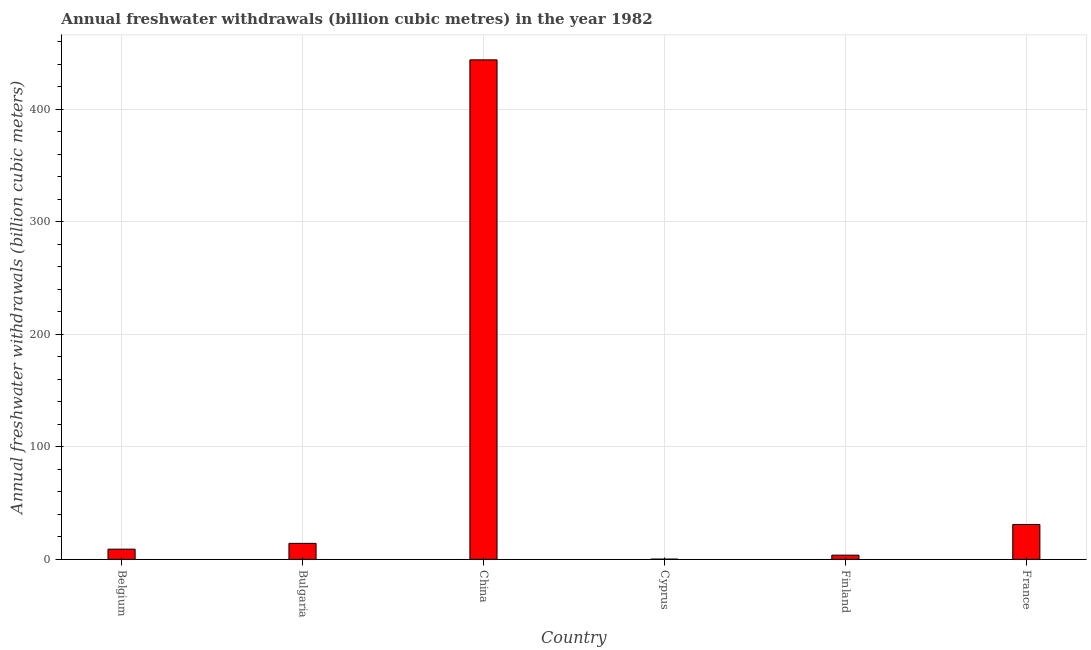Does the graph contain any zero values?
Offer a terse response. No. Does the graph contain grids?
Offer a very short reply. Yes. What is the title of the graph?
Your answer should be compact. Annual freshwater withdrawals (billion cubic metres) in the year 1982. What is the label or title of the Y-axis?
Keep it short and to the point. Annual freshwater withdrawals (billion cubic meters). What is the annual freshwater withdrawals in China?
Your answer should be compact. 443.7. Across all countries, what is the maximum annual freshwater withdrawals?
Provide a succinct answer. 443.7. Across all countries, what is the minimum annual freshwater withdrawals?
Give a very brief answer. 0.18. In which country was the annual freshwater withdrawals maximum?
Ensure brevity in your answer.  China. In which country was the annual freshwater withdrawals minimum?
Make the answer very short. Cyprus. What is the sum of the annual freshwater withdrawals?
Ensure brevity in your answer.  501.76. What is the difference between the annual freshwater withdrawals in Belgium and Finland?
Offer a very short reply. 5.33. What is the average annual freshwater withdrawals per country?
Provide a short and direct response. 83.63. What is the median annual freshwater withdrawals?
Your answer should be very brief. 11.61. What is the ratio of the annual freshwater withdrawals in Bulgaria to that in France?
Provide a succinct answer. 0.46. Is the annual freshwater withdrawals in Belgium less than that in China?
Your answer should be compact. Yes. Is the difference between the annual freshwater withdrawals in China and Cyprus greater than the difference between any two countries?
Offer a very short reply. Yes. What is the difference between the highest and the second highest annual freshwater withdrawals?
Your answer should be very brief. 412.73. Is the sum of the annual freshwater withdrawals in China and France greater than the maximum annual freshwater withdrawals across all countries?
Keep it short and to the point. Yes. What is the difference between the highest and the lowest annual freshwater withdrawals?
Provide a succinct answer. 443.52. In how many countries, is the annual freshwater withdrawals greater than the average annual freshwater withdrawals taken over all countries?
Ensure brevity in your answer.  1. How many bars are there?
Your answer should be very brief. 6. What is the difference between two consecutive major ticks on the Y-axis?
Keep it short and to the point. 100. What is the Annual freshwater withdrawals (billion cubic meters) in Belgium?
Offer a very short reply. 9.03. What is the Annual freshwater withdrawals (billion cubic meters) of Bulgaria?
Offer a very short reply. 14.18. What is the Annual freshwater withdrawals (billion cubic meters) in China?
Make the answer very short. 443.7. What is the Annual freshwater withdrawals (billion cubic meters) of Cyprus?
Ensure brevity in your answer.  0.18. What is the Annual freshwater withdrawals (billion cubic meters) of Finland?
Your answer should be compact. 3.7. What is the Annual freshwater withdrawals (billion cubic meters) in France?
Offer a terse response. 30.97. What is the difference between the Annual freshwater withdrawals (billion cubic meters) in Belgium and Bulgaria?
Your answer should be compact. -5.15. What is the difference between the Annual freshwater withdrawals (billion cubic meters) in Belgium and China?
Provide a short and direct response. -434.67. What is the difference between the Annual freshwater withdrawals (billion cubic meters) in Belgium and Cyprus?
Keep it short and to the point. 8.85. What is the difference between the Annual freshwater withdrawals (billion cubic meters) in Belgium and Finland?
Your answer should be very brief. 5.33. What is the difference between the Annual freshwater withdrawals (billion cubic meters) in Belgium and France?
Make the answer very short. -21.94. What is the difference between the Annual freshwater withdrawals (billion cubic meters) in Bulgaria and China?
Your answer should be compact. -429.52. What is the difference between the Annual freshwater withdrawals (billion cubic meters) in Bulgaria and Cyprus?
Give a very brief answer. 14. What is the difference between the Annual freshwater withdrawals (billion cubic meters) in Bulgaria and Finland?
Provide a short and direct response. 10.48. What is the difference between the Annual freshwater withdrawals (billion cubic meters) in Bulgaria and France?
Make the answer very short. -16.79. What is the difference between the Annual freshwater withdrawals (billion cubic meters) in China and Cyprus?
Keep it short and to the point. 443.52. What is the difference between the Annual freshwater withdrawals (billion cubic meters) in China and Finland?
Your answer should be compact. 440. What is the difference between the Annual freshwater withdrawals (billion cubic meters) in China and France?
Keep it short and to the point. 412.73. What is the difference between the Annual freshwater withdrawals (billion cubic meters) in Cyprus and Finland?
Provide a succinct answer. -3.52. What is the difference between the Annual freshwater withdrawals (billion cubic meters) in Cyprus and France?
Your response must be concise. -30.79. What is the difference between the Annual freshwater withdrawals (billion cubic meters) in Finland and France?
Your answer should be very brief. -27.27. What is the ratio of the Annual freshwater withdrawals (billion cubic meters) in Belgium to that in Bulgaria?
Provide a short and direct response. 0.64. What is the ratio of the Annual freshwater withdrawals (billion cubic meters) in Belgium to that in Cyprus?
Offer a very short reply. 51.02. What is the ratio of the Annual freshwater withdrawals (billion cubic meters) in Belgium to that in Finland?
Your answer should be compact. 2.44. What is the ratio of the Annual freshwater withdrawals (billion cubic meters) in Belgium to that in France?
Your response must be concise. 0.29. What is the ratio of the Annual freshwater withdrawals (billion cubic meters) in Bulgaria to that in China?
Keep it short and to the point. 0.03. What is the ratio of the Annual freshwater withdrawals (billion cubic meters) in Bulgaria to that in Cyprus?
Make the answer very short. 80.11. What is the ratio of the Annual freshwater withdrawals (billion cubic meters) in Bulgaria to that in Finland?
Give a very brief answer. 3.83. What is the ratio of the Annual freshwater withdrawals (billion cubic meters) in Bulgaria to that in France?
Offer a very short reply. 0.46. What is the ratio of the Annual freshwater withdrawals (billion cubic meters) in China to that in Cyprus?
Ensure brevity in your answer.  2506.78. What is the ratio of the Annual freshwater withdrawals (billion cubic meters) in China to that in Finland?
Provide a short and direct response. 119.92. What is the ratio of the Annual freshwater withdrawals (billion cubic meters) in China to that in France?
Your answer should be very brief. 14.33. What is the ratio of the Annual freshwater withdrawals (billion cubic meters) in Cyprus to that in Finland?
Ensure brevity in your answer.  0.05. What is the ratio of the Annual freshwater withdrawals (billion cubic meters) in Cyprus to that in France?
Provide a short and direct response. 0.01. What is the ratio of the Annual freshwater withdrawals (billion cubic meters) in Finland to that in France?
Make the answer very short. 0.12. 